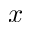Convert formula to latex. <formula><loc_0><loc_0><loc_500><loc_500>x</formula> 